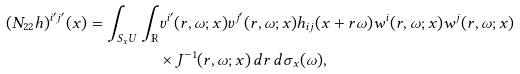Convert formula to latex. <formula><loc_0><loc_0><loc_500><loc_500>( N _ { 2 2 } h ) ^ { i ^ { \prime } j ^ { \prime } } ( x ) = \int _ { S _ { x } U } \int _ { \mathbb { R } } & v ^ { i ^ { \prime } } ( r , \omega ; x ) v ^ { j ^ { \prime } } ( r , \omega ; x ) h _ { i j } ( x + r \omega ) w ^ { i } ( r , \omega ; x ) w ^ { j } ( r , \omega ; x ) \\ & \times J ^ { - 1 } ( r , \omega ; x ) \, d r \, d \sigma _ { x } ( \omega ) ,</formula> 